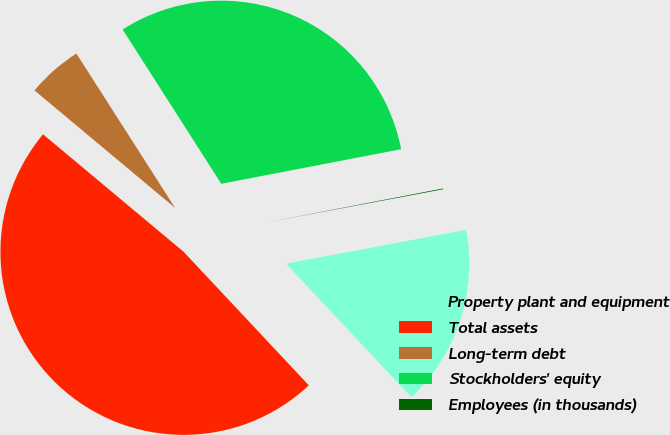<chart> <loc_0><loc_0><loc_500><loc_500><pie_chart><fcel>Property plant and equipment<fcel>Total assets<fcel>Long-term debt<fcel>Stockholders' equity<fcel>Employees (in thousands)<nl><fcel>15.97%<fcel>48.07%<fcel>4.87%<fcel>31.03%<fcel>0.07%<nl></chart> 